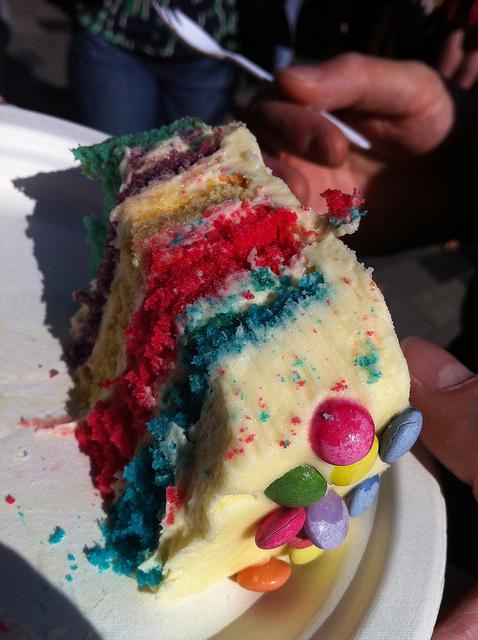Is half of the dessert gone?
Concise answer only. Yes. How many cake layers are there?
Keep it brief. 4. What kind of pastry is this?
Concise answer only. Cake. Is the middle section just very large marshmallows?
Short answer required. No. Is this cake good?
Be succinct. Yes. What kind of cake is this?
Quick response, please. Rainbow. What child friendly candy is decorating this cake?
Be succinct. Skittles. Would this cake be good for you to eat?
Short answer required. Yes. What's the person holding against the food?
Quick response, please. Spoon. Could the sprinkles be chocolate?
Give a very brief answer. Yes. What color plate is the cake on?
Be succinct. White. Are there vegetables in this dish?
Write a very short answer. No. Is this a gummy bear cake?
Give a very brief answer. No. Is there food color on the cake?
Answer briefly. Yes. What color is the inside of the cake?
Be succinct. Rainbow. Why would someone eat this?
Concise answer only. Birthday. What dish is served?
Keep it brief. Cake. What is on the top of the cake?
Concise answer only. Candy. Is there fruit in between the layers of cake?
Short answer required. No. Has this cake been bitten?
Answer briefly. Yes. What would this icing on the cake taste like?
Write a very short answer. Vanilla. What type of cake is this?
Short answer required. Rainbow. What is on top of the cake?
Write a very short answer. Candy. Is the plate on a table?
Answer briefly. No. Is this a birthday cake?
Write a very short answer. Yes. How many flavors of cake were baked?
Write a very short answer. 1. What is the utensil?
Short answer required. Fork. What color is the outer frosting?
Short answer required. White. How many human hands are in this picture?
Concise answer only. 2. What meal could this be eaten for?
Write a very short answer. Dessert. Does this seem like healthy food?
Write a very short answer. No. What kind of food is this?
Keep it brief. Cake. What is the food item on the bottom level?
Give a very brief answer. Cake. What is around the outside of the cake?
Answer briefly. Icing. What color is the plate?
Short answer required. White. Is the fork disposable?
Concise answer only. Yes. What is this food?
Write a very short answer. Cake. What is sticking out of the cake?
Concise answer only. Candy. What utensil is inside the cake?
Write a very short answer. None. What type of frosting was used for this cake?
Keep it brief. Vanilla. Is this a desert item?
Keep it brief. Yes. How many layers are there?
Be succinct. 5. What event is this cake for?
Concise answer only. Birthday. Is this a dessert cake?
Answer briefly. Yes. How many slices are cut into the cake?
Concise answer only. 1. 